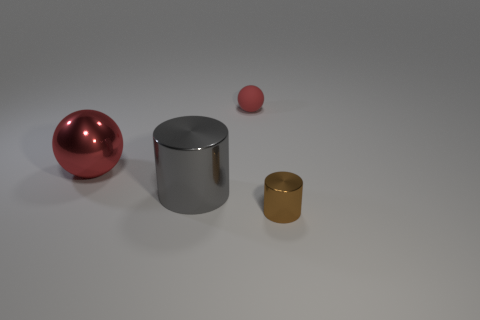Add 3 purple matte objects. How many objects exist? 7 Add 1 small red things. How many small red things exist? 2 Subtract 0 yellow cubes. How many objects are left? 4 Subtract all gray metallic things. Subtract all big cylinders. How many objects are left? 2 Add 1 small red matte balls. How many small red matte balls are left? 2 